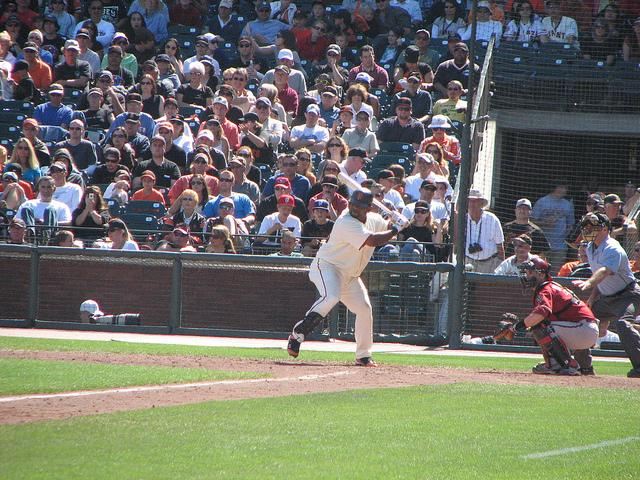What is different about this batter from most batters?

Choices:
A) gender
B) height
C) left-handed batter
D) age left-handed batter 